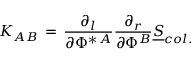Convert formula to latex. <formula><loc_0><loc_0><loc_500><loc_500>K _ { A B } \, = \, { \frac { \partial _ { l } } { \partial \Phi ^ { \ast \, A } } } { \frac { \partial _ { r } } { \partial \Phi ^ { B } } } { \underline { S } } _ { c o l . }</formula> 